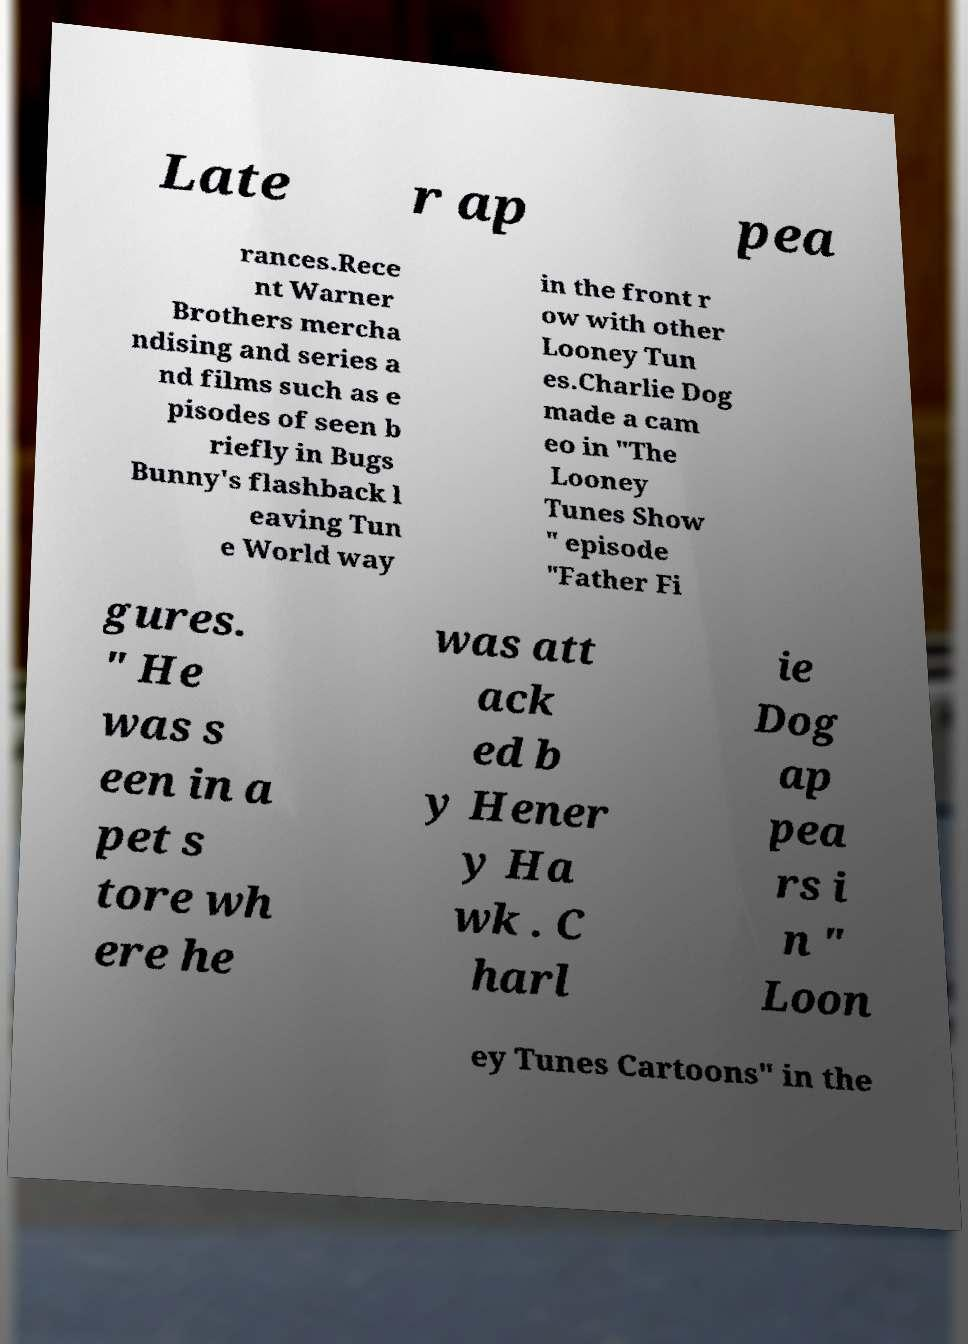For documentation purposes, I need the text within this image transcribed. Could you provide that? Late r ap pea rances.Rece nt Warner Brothers mercha ndising and series a nd films such as e pisodes of seen b riefly in Bugs Bunny's flashback l eaving Tun e World way in the front r ow with other Looney Tun es.Charlie Dog made a cam eo in "The Looney Tunes Show " episode "Father Fi gures. " He was s een in a pet s tore wh ere he was att ack ed b y Hener y Ha wk . C harl ie Dog ap pea rs i n " Loon ey Tunes Cartoons" in the 